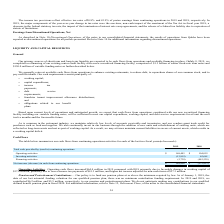According to Jack In The Box's financial document, How much did operating cash flows increased by from 2018 to 2019? According to the financial document, $64.4 million. The relevant text states: "rating Activities . Operating cash flows increased $64.4 million in 2019 compared with 2018 primarily due to favorable changes in working capital of..." Also, How much money was contributed to the pension and postretirement plan in 2019? According to the financial document, $6.2 million. The relevant text states: "ding requirement. In 2019 and 2018, we contributed $6.2 million and $5.5 million, respectively, to our pension and postretirement plans. We do not anticipate making..." Also, How much money was contributed to the pension and postretirement plan in 2018? According to the financial document, $5.5 million. The relevant text states: "In 2019 and 2018, we contributed $6.2 million and $5.5 million, respectively, to our pension and postretirement plans. We do not anticipate making any contributio..." Also, can you calculate: What is the average of the cash flows for operating activities for 2018 and 2019? To answer this question, I need to perform calculations using the financial data. The calculation is: ($168,405 + $104,055)/2, which equals 136230 (in thousands). This is based on the information: "Operating activities $ 168,405 $ 104,055 Operating activities $ 168,405 $ 104,055..." The key data points involved are: 104,055, 168,405. Also, can you calculate: What is the difference in cash flows for investing activities between 2018 and 2019? Based on the calculation: $65,661 + $13,819 , the result is 79480 (in thousands). This is based on the information: "Investing activities (13,819) 65,661 Investing activities (13,819) 65,661..." The key data points involved are: 13,819, 65,661. Also, can you calculate: What is the percentage change in cash flows from operating activities from 2018 to 2019? To answer this question, I need to perform calculations using the financial data. The calculation is: ($168,405 - $104,055)/$104,055 , which equals 61.84 (percentage). This is based on the information: "Operating activities $ 168,405 $ 104,055 Operating activities $ 168,405 $ 104,055..." The key data points involved are: 104,055, 168,405. 